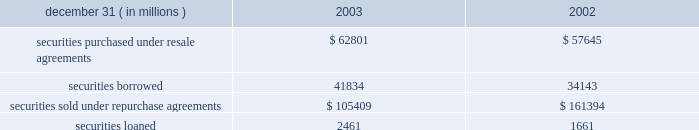Notes to consolidated financial statements j.p .
Morgan chase & co .
98 j.p .
Morgan chase & co .
/ 2003 annual report securities financing activities jpmorgan chase enters into resale agreements , repurchase agreements , securities borrowed transactions and securities loaned transactions primarily to finance the firm 2019s inventory positions , acquire securities to cover short positions and settle other securities obligations .
The firm also enters into these transactions to accommodate customers 2019 needs .
Securities purchased under resale agreements ( 201cresale agreements 201d ) and securities sold under repurchase agreements ( 201crepurchase agreements 201d ) are generally treated as collateralized financing transactions and are carried on the consolidated bal- ance sheet at the amounts the securities will be subsequently sold or repurchased , plus accrued interest .
Where appropriate , resale and repurchase agreements with the same counterparty are reported on a net basis in accordance with fin 41 .
Jpmorgan chase takes possession of securities purchased under resale agreements .
On a daily basis , jpmorgan chase monitors the market value of the underlying collateral received from its counterparties , consisting primarily of u.s .
And non-u.s .
Govern- ment and agency securities , and requests additional collateral from its counterparties when necessary .
Similar transactions that do not meet the sfas 140 definition of a repurchase agreement are accounted for as 201cbuys 201d and 201csells 201d rather than financing transactions .
These transactions are accounted for as a purchase ( sale ) of the underlying securities with a forward obligation to sell ( purchase ) the securities .
The forward purchase ( sale ) obligation , a derivative , is recorded on the consolidated balance sheet at its fair value , with changes in fair value recorded in trading revenue .
Notional amounts of these transactions accounted for as purchases under sfas 140 were $ 15 billion and $ 8 billion at december 31 , 2003 and 2002 , respectively .
Notional amounts of these transactions accounted for as sales under sfas 140 were $ 8 billion and $ 13 billion at december 31 , 2003 and 2002 , respectively .
Based on the short-term duration of these contracts , the unrealized gain or loss is insignificant .
Securities borrowed and securities lent are recorded at the amount of cash collateral advanced or received .
Securities bor- rowed consist primarily of government and equity securities .
Jpmorgan chase monitors the market value of the securities borrowed and lent on a daily basis and calls for additional col- lateral when appropriate .
Fees received or paid are recorded in interest income or interest expense. .
Note 10 jpmorgan chase pledges certain financial instruments it owns to collateralize repurchase agreements and other securities financ- ings .
Pledged securities that can be sold or repledged by the secured party are identified as financial instruments owned ( pledged to various parties ) on the consolidated balance sheet .
At december 31 , 2003 , the firm had received securities as col- lateral that can be repledged , delivered or otherwise used with a fair value of approximately $ 210 billion .
This collateral was gen- erally obtained under resale or securities-borrowing agreements .
Of these securities , approximately $ 197 billion was repledged , delivered or otherwise used , generally as collateral under repur- chase agreements , securities-lending agreements or to cover short sales .
Notes to consolidated financial statements j.p .
Morgan chase & co .
Loans are reported at the principal amount outstanding , net of the allowance for loan losses , unearned income and any net deferred loan fees .
Loans held for sale are carried at the lower of aggregate cost or fair value .
Loans are classified as 201ctrading 201d for secondary market trading activities where positions are bought and sold to make profits from short-term movements in price .
Loans held for trading purposes are included in trading assets and are carried at fair value , with the gains and losses included in trading revenue .
Interest income is recognized using the interest method , or on a basis approximating a level rate of return over the term of the loan .
Nonaccrual loans are those on which the accrual of interest is discontinued .
Loans ( other than certain consumer loans discussed below ) are placed on nonaccrual status immediately if , in the opinion of management , full payment of principal or interest is in doubt , or when principal or interest is 90 days or more past due and collateral , if any , is insufficient to cover prin- cipal and interest .
Interest accrued but not collected at the date a loan is placed on nonaccrual status is reversed against interest income .
In addition , the amortization of net deferred loan fees is suspended .
Interest income on nonaccrual loans is recognized only to the extent it is received in cash .
However , where there is doubt regarding the ultimate collectibility of loan principal , all cash thereafter received is applied to reduce the carrying value of the loan .
Loans are restored to accrual status only when interest and principal payments are brought current and future payments are reasonably assured .
Consumer loans are generally charged to the allowance for loan losses upon reaching specified stages of delinquency , in accor- dance with the federal financial institutions examination council ( 201cffiec 201d ) policy .
For example , credit card loans are charged off at the earlier of 180 days past due or within 60 days from receiving notification of the filing of bankruptcy .
Residential mortgage products are generally charged off to net realizable value at 180 days past due .
Other consumer products are gener- ally charged off ( to net realizable value if collateralized ) at 120 days past due .
Accrued interest on residential mortgage products , automobile financings and certain other consumer loans are accounted for in accordance with the nonaccrual loan policy note 11 .
What was the net notional amounts of purchases and sales under sfas 140 in 2003 ( us$ b ) ? 
Computations: (15 - 8)
Answer: 7.0. 